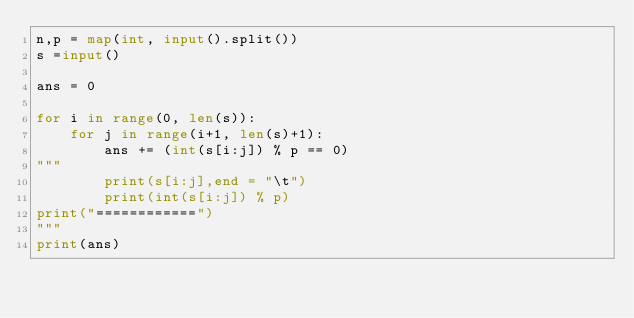Convert code to text. <code><loc_0><loc_0><loc_500><loc_500><_Python_>n,p = map(int, input().split())
s =input()

ans = 0

for i in range(0, len(s)):
    for j in range(i+1, len(s)+1):
        ans += (int(s[i:j]) % p == 0)
"""
        print(s[i:j],end = "\t")
        print(int(s[i:j]) % p)
print("============")
"""
print(ans)</code> 